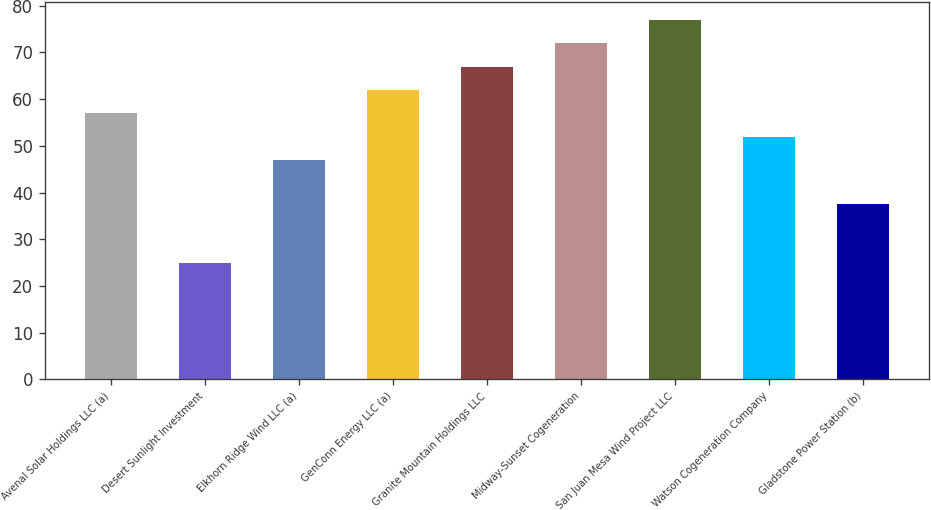Convert chart to OTSL. <chart><loc_0><loc_0><loc_500><loc_500><bar_chart><fcel>Avenal Solar Holdings LLC (a)<fcel>Desert Sunlight Investment<fcel>Elkhorn Ridge Wind LLC (a)<fcel>GenConn Energy LLC (a)<fcel>Granite Mountain Holdings LLC<fcel>Midway-Sunset Cogeneration<fcel>San Juan Mesa Wind Project LLC<fcel>Watson Cogeneration Company<fcel>Gladstone Power Station (b)<nl><fcel>57<fcel>25<fcel>47<fcel>62<fcel>67<fcel>72<fcel>77<fcel>52<fcel>37.5<nl></chart> 